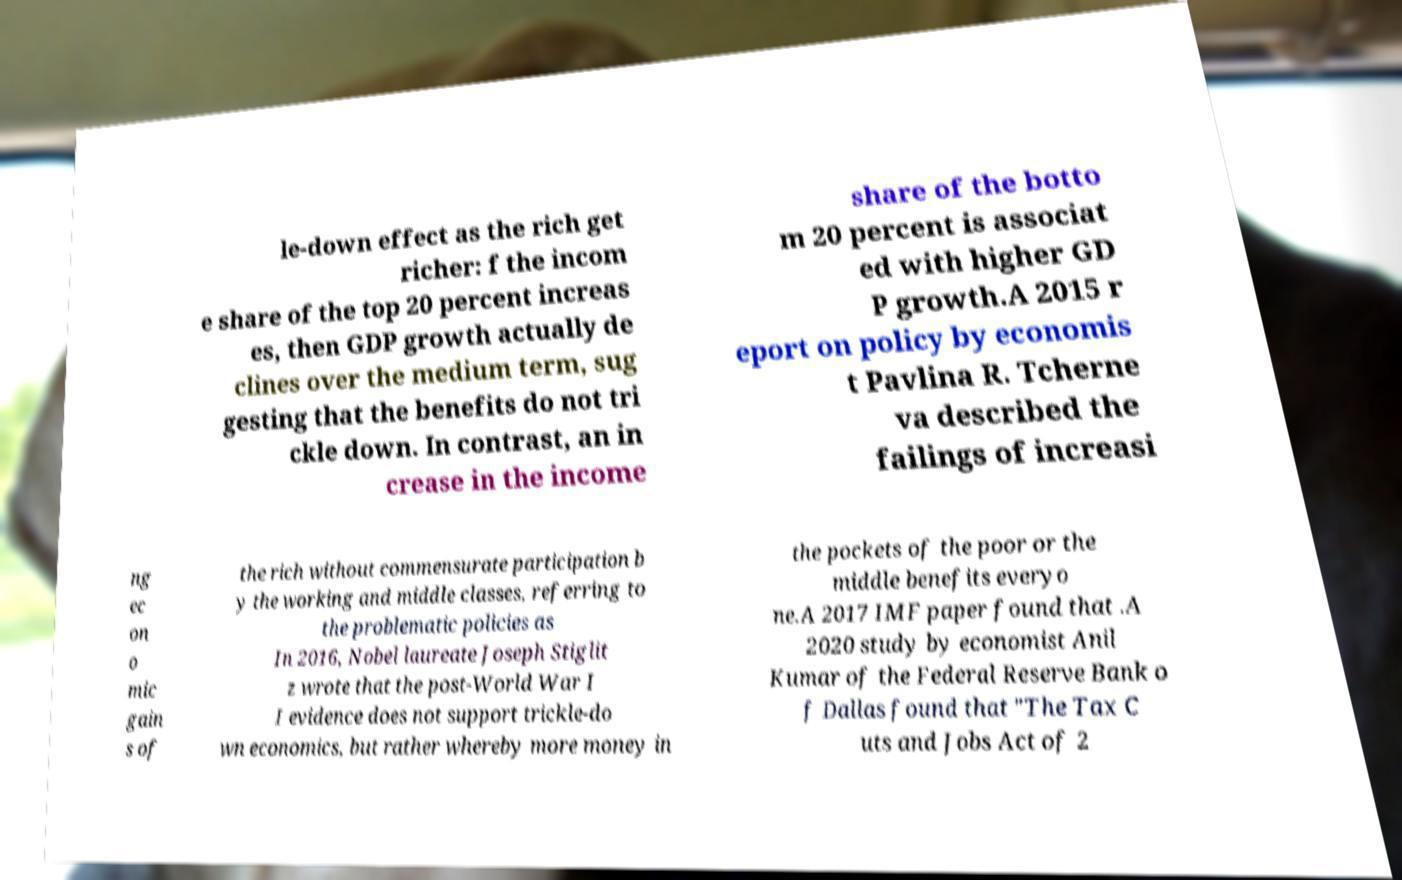I need the written content from this picture converted into text. Can you do that? le-down effect as the rich get richer: f the incom e share of the top 20 percent increas es, then GDP growth actually de clines over the medium term, sug gesting that the benefits do not tri ckle down. In contrast, an in crease in the income share of the botto m 20 percent is associat ed with higher GD P growth.A 2015 r eport on policy by economis t Pavlina R. Tcherne va described the failings of increasi ng ec on o mic gain s of the rich without commensurate participation b y the working and middle classes, referring to the problematic policies as In 2016, Nobel laureate Joseph Stiglit z wrote that the post-World War I I evidence does not support trickle-do wn economics, but rather whereby more money in the pockets of the poor or the middle benefits everyo ne.A 2017 IMF paper found that .A 2020 study by economist Anil Kumar of the Federal Reserve Bank o f Dallas found that "The Tax C uts and Jobs Act of 2 